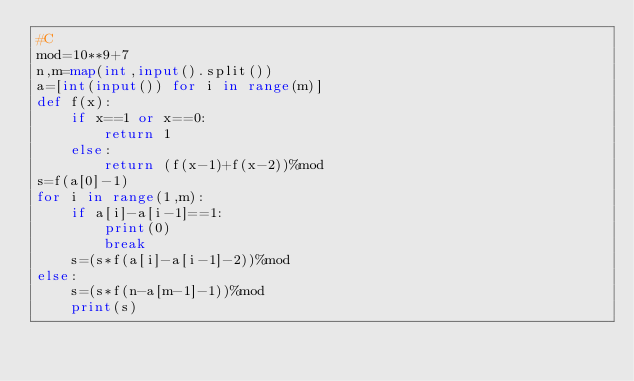Convert code to text. <code><loc_0><loc_0><loc_500><loc_500><_Python_>#C
mod=10**9+7
n,m=map(int,input().split())
a=[int(input()) for i in range(m)]
def f(x):
    if x==1 or x==0:
        return 1
    else:
        return (f(x-1)+f(x-2))%mod
s=f(a[0]-1)
for i in range(1,m):
    if a[i]-a[i-1]==1:
        print(0)
        break
    s=(s*f(a[i]-a[i-1]-2))%mod
else:
    s=(s*f(n-a[m-1]-1))%mod
    print(s)</code> 